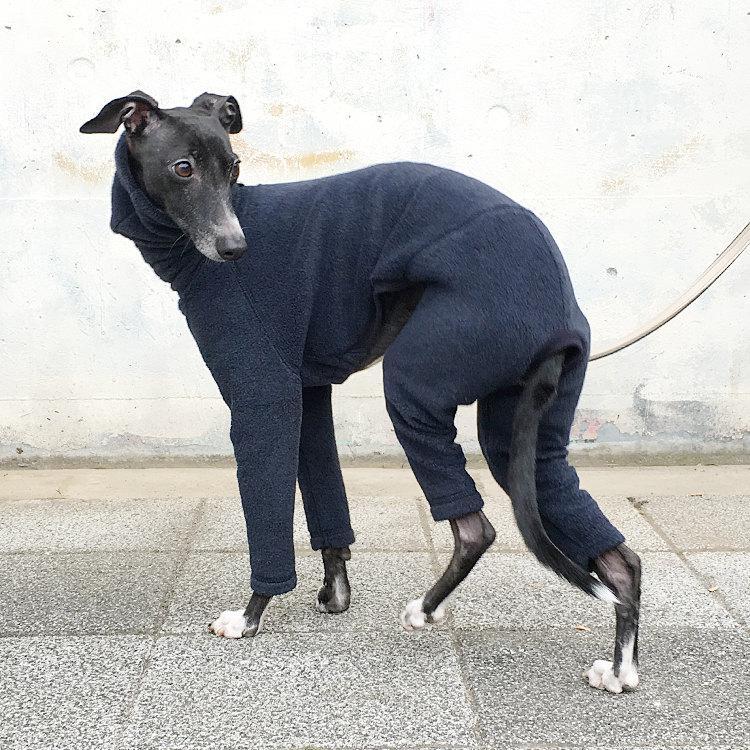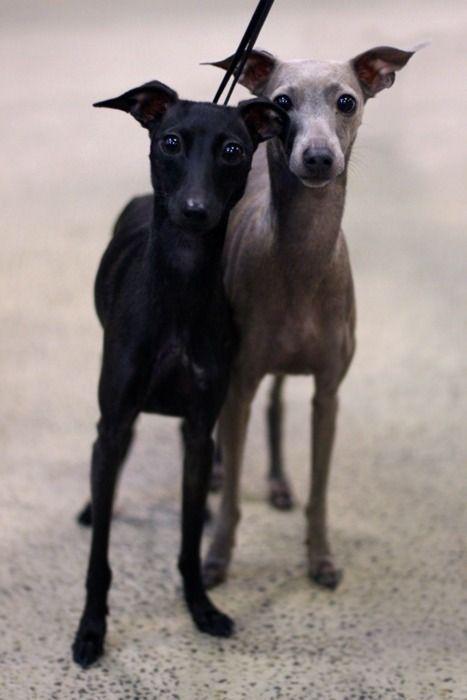The first image is the image on the left, the second image is the image on the right. For the images displayed, is the sentence "The dog in one of the images is on a cemented area outside." factually correct? Answer yes or no. Yes. The first image is the image on the left, the second image is the image on the right. For the images displayed, is the sentence "An image shows a dog wearing a garment with a turtleneck." factually correct? Answer yes or no. Yes. 